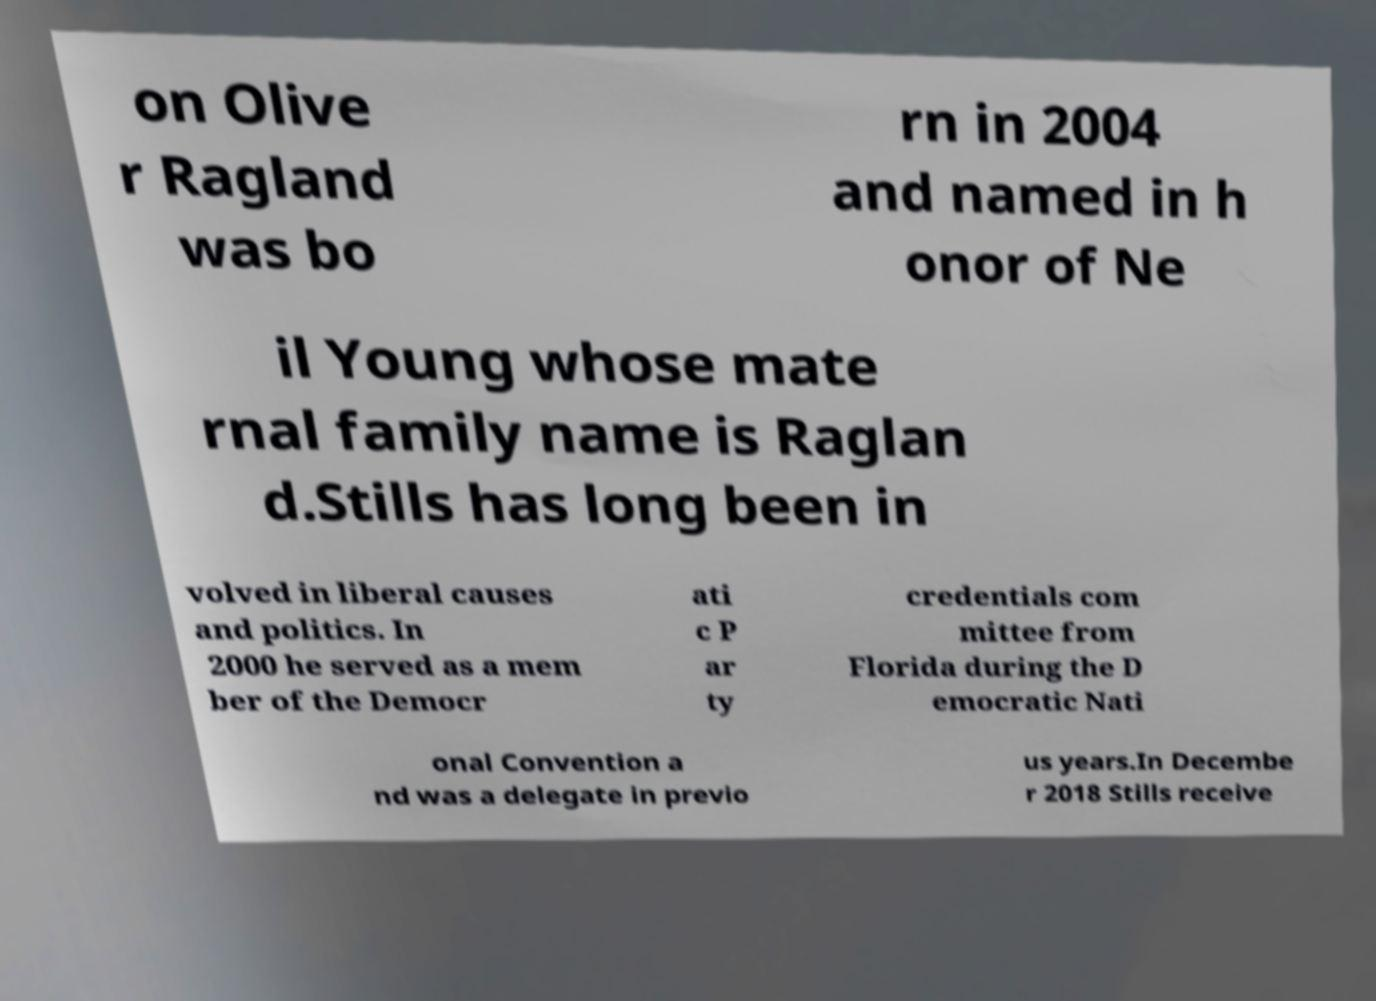Could you extract and type out the text from this image? on Olive r Ragland was bo rn in 2004 and named in h onor of Ne il Young whose mate rnal family name is Raglan d.Stills has long been in volved in liberal causes and politics. In 2000 he served as a mem ber of the Democr ati c P ar ty credentials com mittee from Florida during the D emocratic Nati onal Convention a nd was a delegate in previo us years.In Decembe r 2018 Stills receive 